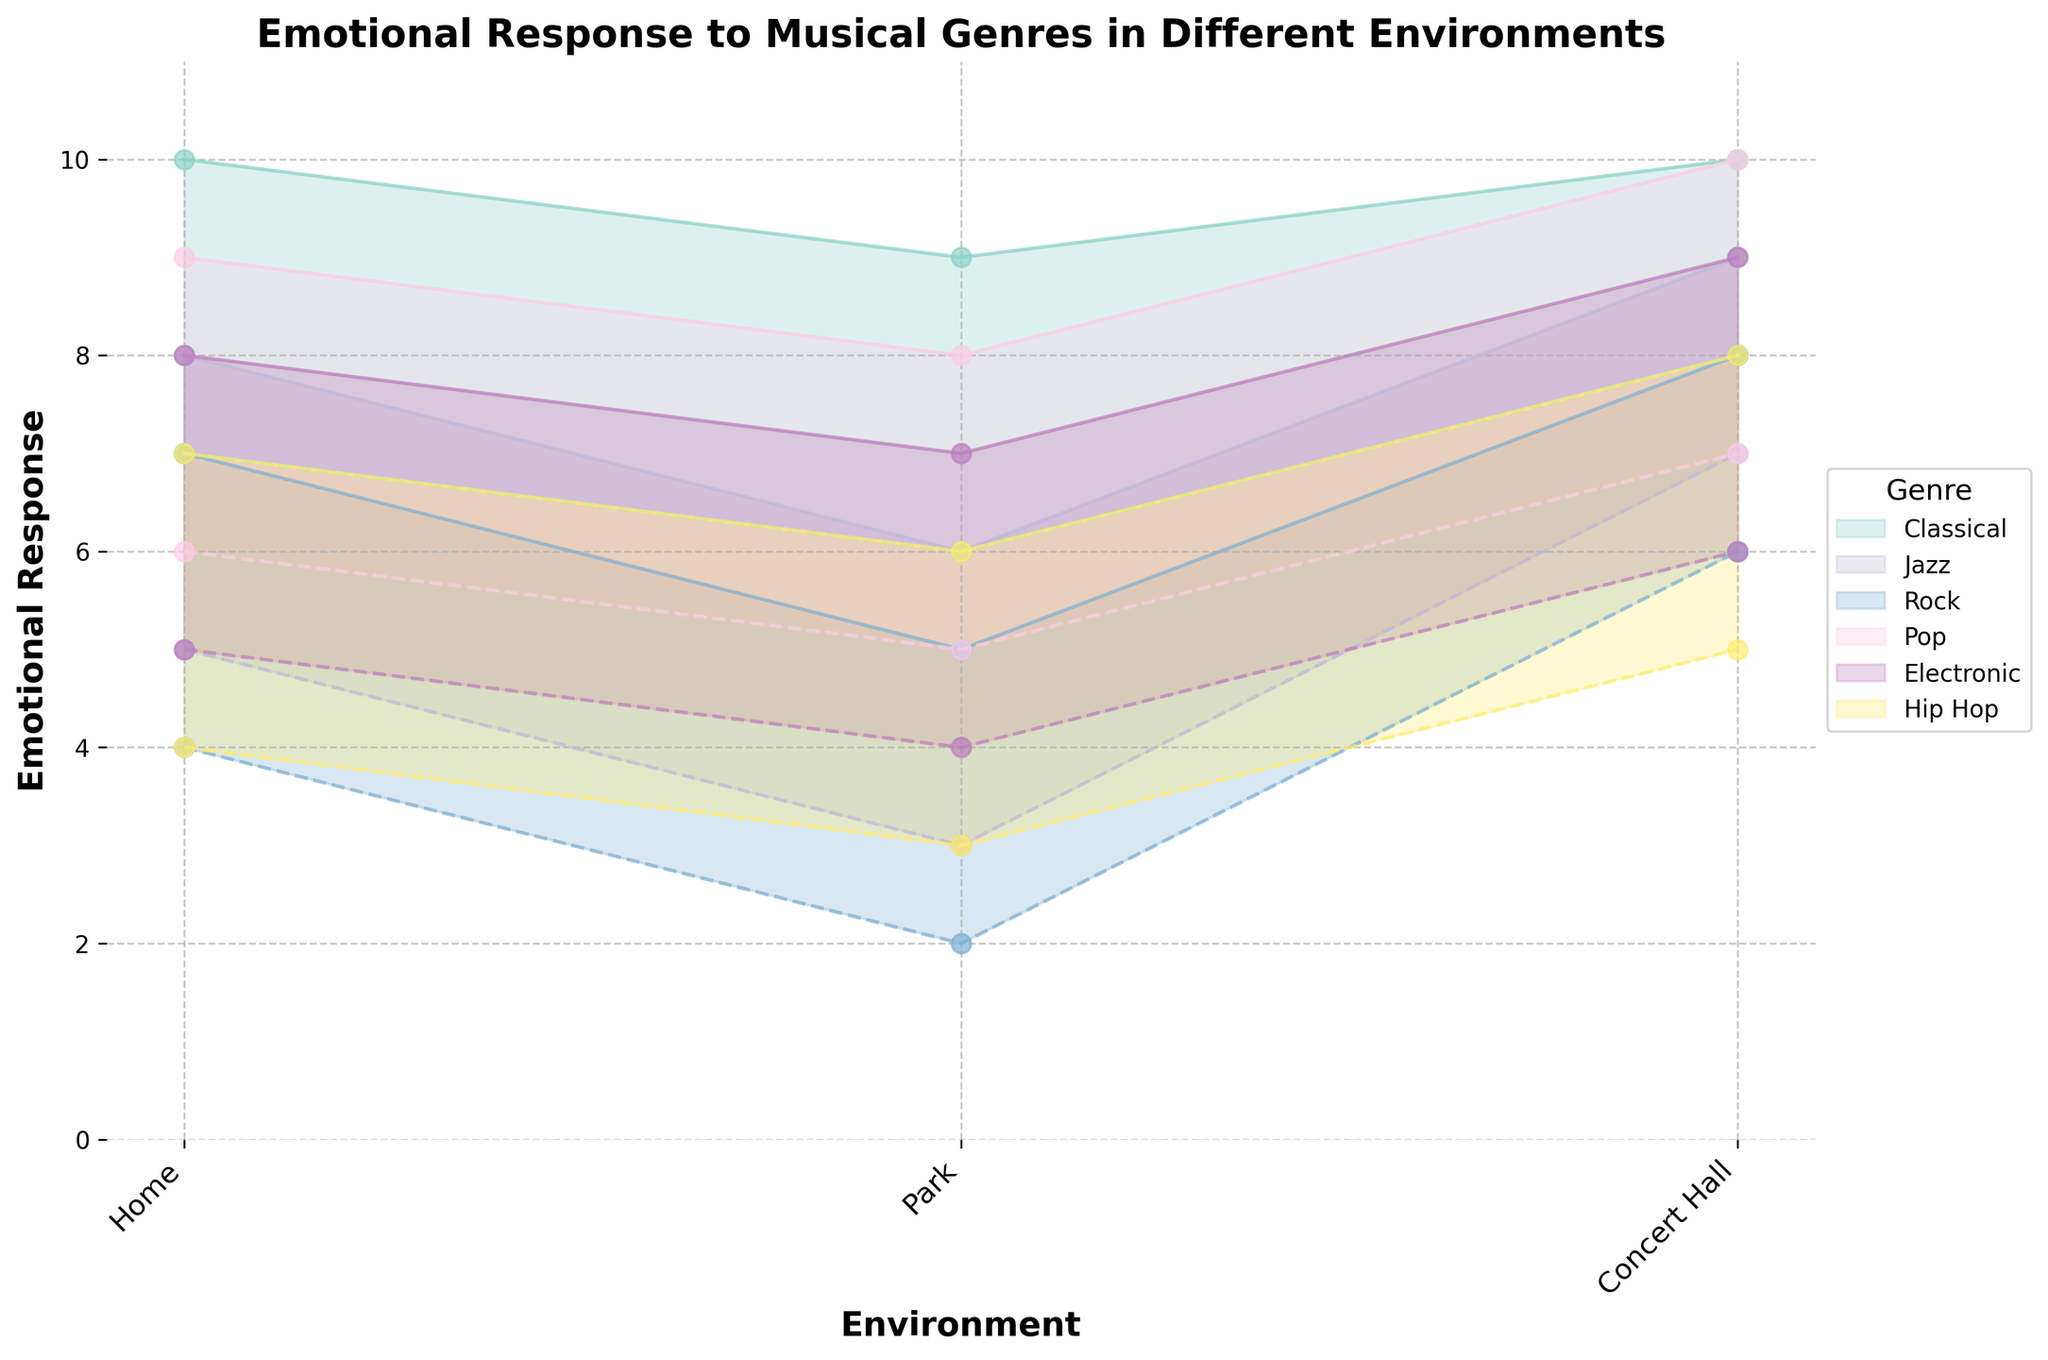What is the title of the figure? The title is usually prominently displayed above the chart and describes the content of the figure. Here, it is "Emotional Response to Musical Genres in Different Environments" as indicated by the code.
Answer: Emotional Response to Musical Genres in Different Environments Which genre has the widest range of emotional response in a home environment? To determine this, we look at the difference between the maximum and minimum response for each genre in the home environment. The genre with the largest difference shows the widest range. For Classical (10-7=3), Jazz (8-5=3), Rock (7-4=3), Pop (9-6=3), Electronic (8-5=3), and Hip Hop (7-4=3), all have a range of 3.
Answer: Classical, Jazz, Rock, Pop, Electronic, and Hip Hop In which environment does Hip Hop have the lowest minimum emotional response? We locate the data points for Hip Hop and compare the minimum values across different environments. Hip Hop in Park has the lowest value of 3, compared to Home (4) and Concert Hall (5).
Answer: Park Between which two environments does Classical music's emotional response range overlap the most? We compare the ranges of emotional response for Classical music in different environments. Both Home (7-10) overlaps with Park (6-9) and Concert Hall (8-10). Therefore, Park and Home have the most overlap in their ranges (7-9).
Answer: Home and Park Which genre has consistently higher emotional response across all environments? By examining the chart, we need to compare the minimum and maximum emotional responses of each genre across all environments. Classical has high ranges across all environments (7-10, 6-9, 8-10).
Answer: Classical For Pop music, how does the emotional response range in a park compare to the same range in a concert hall? In a park, the emotional response ranges from 5 to 8, while in a concert hall, it ranges from 7 to 10. We compare the lower and upper bounds to see that both the minimum and maximum values are higher in a concert hall.
Answer: Higher in a concert hall What's the average minimum emotional response for Rock music across all environments? We find the minimum values for Rock music across the environments: 4 (Home), 2 (Park), 6 (Concert Hall). Sum these values (4+2+6=12) and divide by the number of environments (3). 12/3 = 4.
Answer: 4 Which genre has the most significant increase in emotional response from the park to the concert hall environment? To determine the genre with the most significant increase, we calculate the difference in maximum responses from park to concert hall for each genre and identify the largest difference. Classical: 9-6=3, Jazz: 9-6=3, Rock: 8-5=3, Pop: 10-8=2, Electronic: 9-7=2, Hip Hop: 8-6=2. Classical, Jazz, and Rock have the same highest increase of 3.
Answer: Classical, Jazz, and Rock 